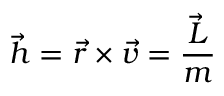Convert formula to latex. <formula><loc_0><loc_0><loc_500><loc_500>{ \vec { h } } = { \vec { r } } \times { \vec { v } } = { \frac { \vec { L } } { m } }</formula> 